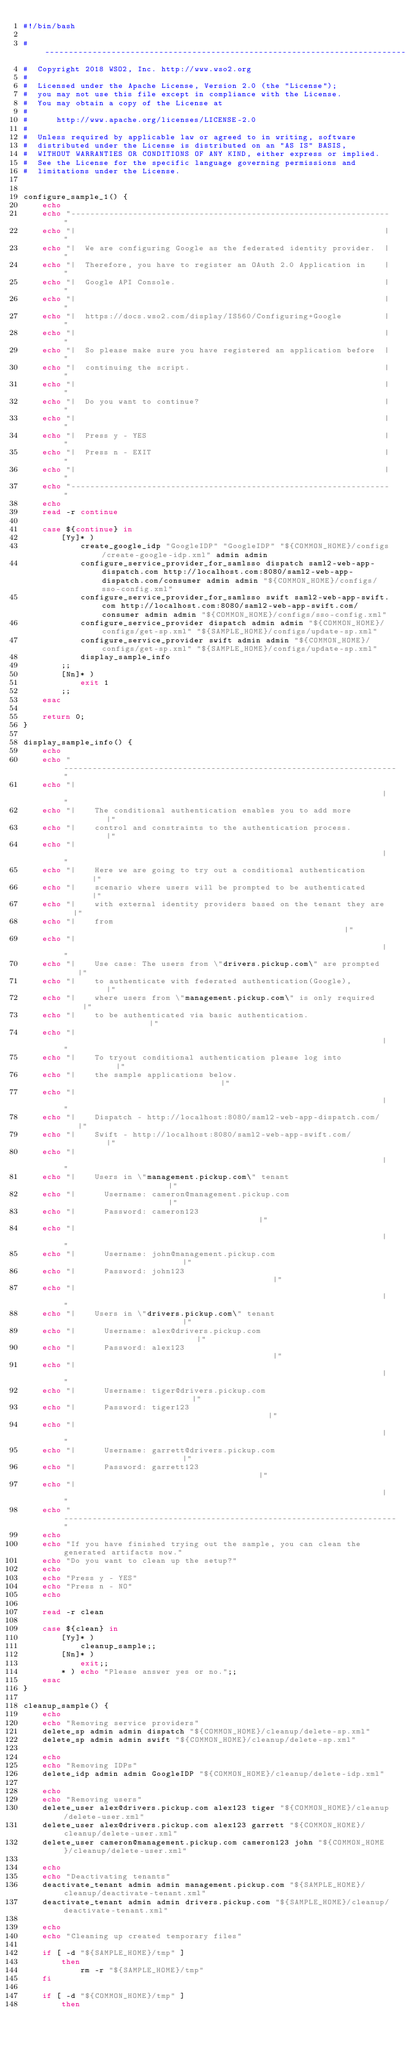Convert code to text. <code><loc_0><loc_0><loc_500><loc_500><_Bash_>#!/bin/bash

# ----------------------------------------------------------------------------
#  Copyright 2018 WSO2, Inc. http://www.wso2.org
#
#  Licensed under the Apache License, Version 2.0 (the "License");
#  you may not use this file except in compliance with the License.
#  You may obtain a copy of the License at
#
#      http://www.apache.org/licenses/LICENSE-2.0
#
#  Unless required by applicable law or agreed to in writing, software
#  distributed under the License is distributed on an "AS IS" BASIS,
#  WITHOUT WARRANTIES OR CONDITIONS OF ANY KIND, either express or implied.
#  See the License for the specific language governing permissions and
#  limitations under the License.


configure_sample_1() {
    echo
    echo "-------------------------------------------------------------------"
    echo "|                                                                 |"
    echo "|  We are configuring Google as the federated identity provider.  |"
    echo "|  Therefore, you have to register an OAuth 2.0 Application in    |"
    echo "|  Google API Console.                                            |"
    echo "|                                                                 |"
    echo "|  https://docs.wso2.com/display/IS560/Configuring+Google         |"
    echo "|                                                                 |"
    echo "|  So please make sure you have registered an application before  |"
    echo "|  continuing the script.                                         |"
    echo "|                                                                 |"
    echo "|  Do you want to continue?                                       |"
    echo "|                                                                 |"
    echo "|  Press y - YES                                                  |"
    echo "|  Press n - EXIT                                                 |"
    echo "|                                                                 |"
    echo "-------------------------------------------------------------------"
    echo
    read -r continue

    case ${continue} in
        [Yy]* )
            create_google_idp "GoogleIDP" "GoogleIDP" "${COMMON_HOME}/configs/create-google-idp.xml" admin admin
            configure_service_provider_for_samlsso dispatch saml2-web-app-dispatch.com http://localhost.com:8080/saml2-web-app-dispatch.com/consumer admin admin "${COMMON_HOME}/configs/sso-config.xml"
            configure_service_provider_for_samlsso swift saml2-web-app-swift.com http://localhost.com:8080/saml2-web-app-swift.com/consumer admin admin "${COMMON_HOME}/configs/sso-config.xml"
            configure_service_provider dispatch admin admin "${COMMON_HOME}/configs/get-sp.xml" "${SAMPLE_HOME}/configs/update-sp.xml"
            configure_service_provider swift admin admin "${COMMON_HOME}/configs/get-sp.xml" "${SAMPLE_HOME}/configs/update-sp.xml"
            display_sample_info
        ;;
        [Nn]* )
            exit 1
        ;;
    esac

    return 0;
}

display_sample_info() {
    echo
    echo "----------------------------------------------------------------------"
    echo "|                                                                    |"
    echo "|    The conditional authentication enables you to add more          |"
    echo "|    control and constraints to the authentication process.          |"
    echo "|                                                                    |"
    echo "|    Here we are going to try out a conditional authentication       |"
    echo "|    scenario where users will be prompted to be authenticated       |"
    echo "|    with external identity providers based on the tenant they are   |"
    echo "|    from                                                            |"
    echo "|                                                                    |"
    echo "|    Use case: The users from \"drivers.pickup.com\" are prompted    |"
    echo "|    to authenticate with federated authentication(Google),          |"
    echo "|    where users from \"management.pickup.com\" is only required     |"
    echo "|    to be authenticated via basic authentication.                   |"
    echo "|                                                                    |"
    echo "|    To tryout conditional authentication please log into            |"
    echo "|    the sample applications below.                                  |"
    echo "|                                                                    |"
    echo "|    Dispatch - http://localhost:8080/saml2-web-app-dispatch.com/    |"
    echo "|    Swift - http://localhost:8080/saml2-web-app-swift.com/          |"
    echo "|                                                                    |"
    echo "|    Users in \"management.pickup.com\" tenant                       |"
    echo "|      Username: cameron@management.pickup.com                       |"
    echo "|      Password: cameron123                                          |"
    echo "|                                                                    |"
    echo "|      Username: john@management.pickup.com                          |"
    echo "|      Password: john123                                             |"
    echo "|                                                                    |"
    echo "|    Users in \"drivers.pickup.com\" tenant                          |"
    echo "|      Username: alex@drivers.pickup.com                             |"
    echo "|      Password: alex123                                             |"
    echo "|                                                                    |"
    echo "|      Username: tiger@drivers.pickup.com                            |"
    echo "|      Password: tiger123                                            |"
    echo "|                                                                    |"
    echo "|      Username: garrett@drivers.pickup.com                          |"
    echo "|      Password: garrett123                                          |"
    echo "|                                                                    |"
    echo "----------------------------------------------------------------------"
    echo
    echo "If you have finished trying out the sample, you can clean the generated artifacts now."
    echo "Do you want to clean up the setup?"
    echo
    echo "Press y - YES"
    echo "Press n - NO"
    echo

    read -r clean

    case ${clean} in
        [Yy]* )
            cleanup_sample;;
        [Nn]* )
            exit;;
        * ) echo "Please answer yes or no.";;
    esac
}

cleanup_sample() {
    echo
    echo "Removing service providers"
    delete_sp admin admin dispatch "${COMMON_HOME}/cleanup/delete-sp.xml"
    delete_sp admin admin swift "${COMMON_HOME}/cleanup/delete-sp.xml"

    echo
    echo "Removing IDPs"
    delete_idp admin admin GoogleIDP "${COMMON_HOME}/cleanup/delete-idp.xml"

    echo
    echo "Removing users"
    delete_user alex@drivers.pickup.com alex123 tiger "${COMMON_HOME}/cleanup/delete-user.xml"
    delete_user alex@drivers.pickup.com alex123 garrett "${COMMON_HOME}/cleanup/delete-user.xml"
    delete_user cameron@management.pickup.com cameron123 john "${COMMON_HOME}/cleanup/delete-user.xml"

    echo
    echo "Deactivating tenants"
    deactivate_tenant admin admin management.pickup.com "${SAMPLE_HOME}/cleanup/deactivate-tenant.xml"
    deactivate_tenant admin admin drivers.pickup.com "${SAMPLE_HOME}/cleanup/deactivate-tenant.xml"

    echo
    echo "Cleaning up created temporary files"

    if [ -d "${SAMPLE_HOME}/tmp" ]
        then
            rm -r "${SAMPLE_HOME}/tmp"
    fi

    if [ -d "${COMMON_HOME}/tmp" ]
        then</code> 